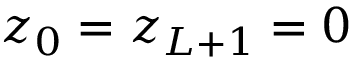<formula> <loc_0><loc_0><loc_500><loc_500>z _ { 0 } = z _ { L + 1 } = 0</formula> 